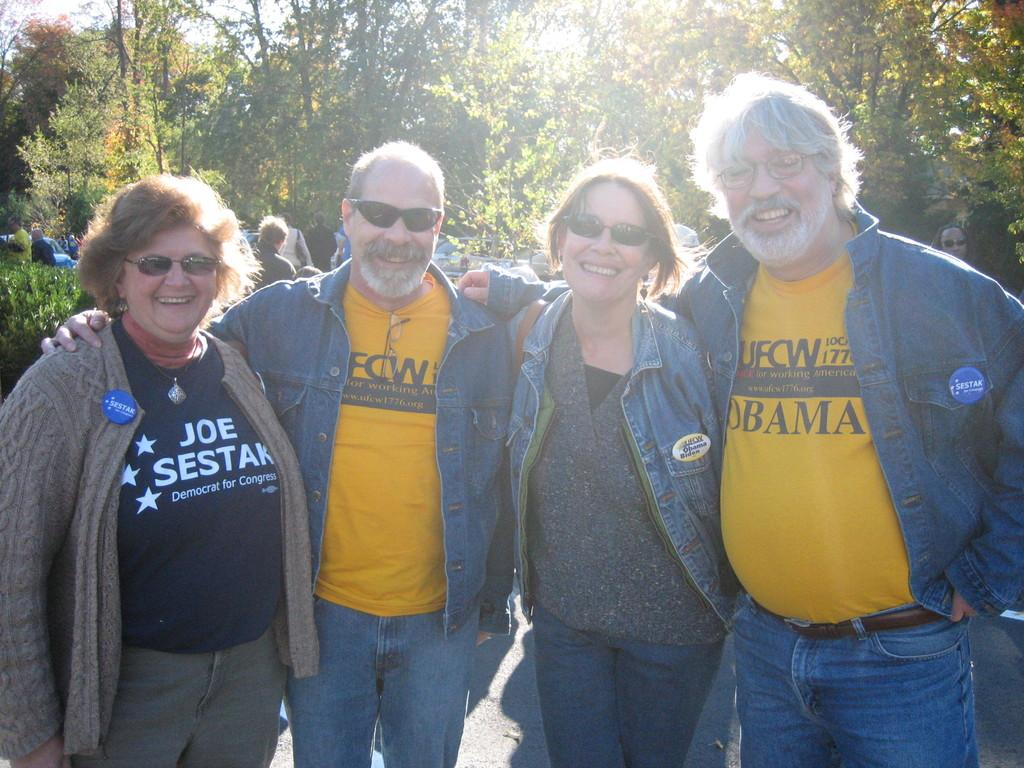How many people are in the foreground of the image? There are four persons standing and posing to the camera in the foreground of the image. Can you describe the people in the background of the image? There are additional persons in the background of the image. What can be seen in the background of the image besides the people? Trees and the sky are visible in the background of the image. What type of air exchange system is visible in the image? There is no air exchange system present in the image. What type of journey are the people in the image embarking on? The image does not provide any information about a journey or the intentions of the people in the image. 